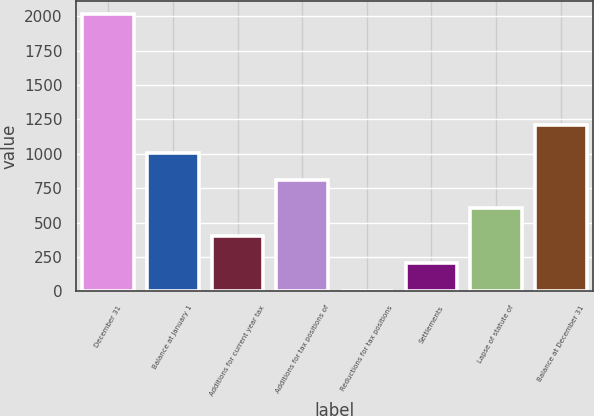<chart> <loc_0><loc_0><loc_500><loc_500><bar_chart><fcel>December 31<fcel>Balance at January 1<fcel>Additions for current year tax<fcel>Additions for tax positions of<fcel>Reductions for tax positions<fcel>Settlements<fcel>Lapse of statute of<fcel>Balance at December 31<nl><fcel>2014<fcel>1008<fcel>404.4<fcel>806.8<fcel>2<fcel>203.2<fcel>605.6<fcel>1209.2<nl></chart> 